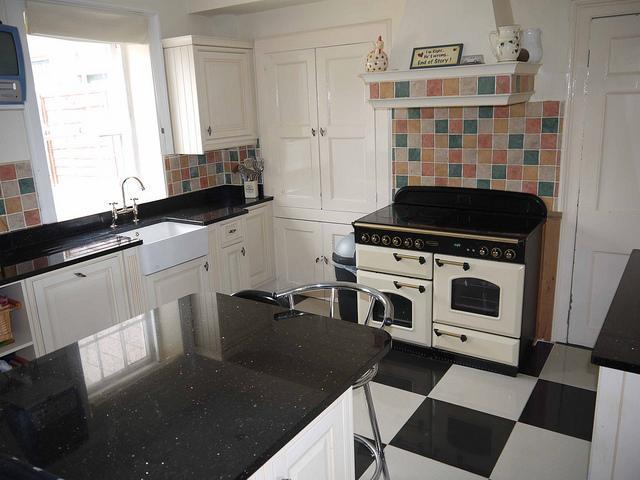How many electrical appliances are showing?
Give a very brief answer. 1. How many knobs are on the stove?
Give a very brief answer. 9. 